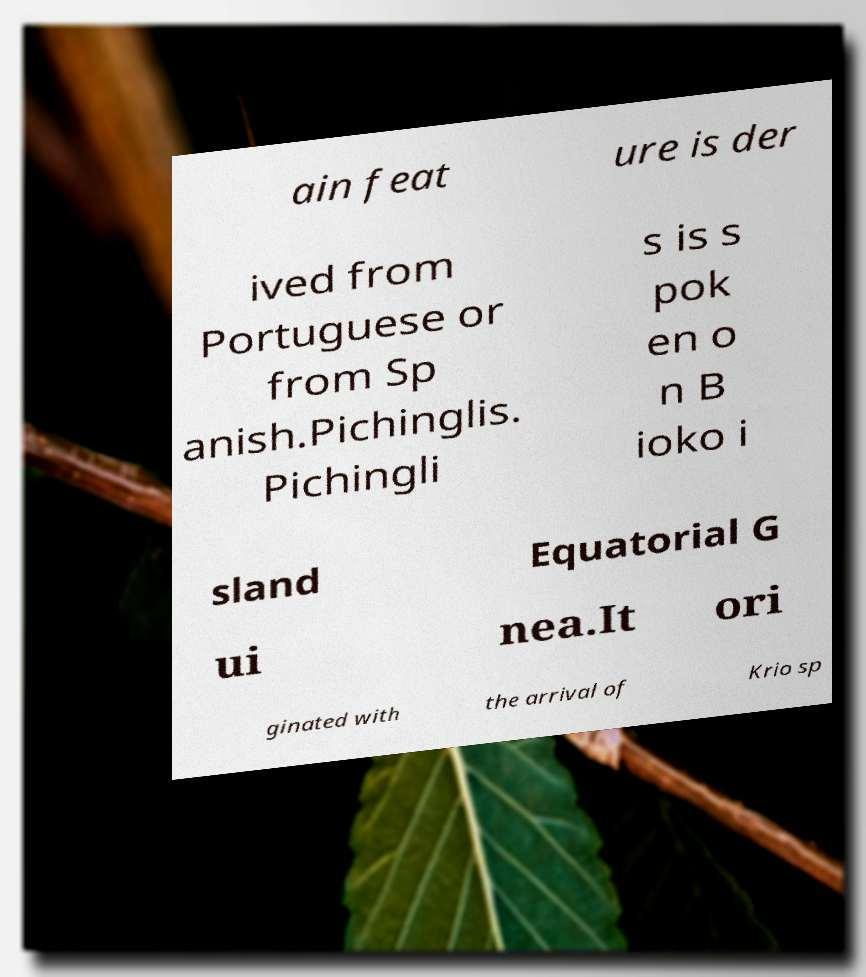Can you read and provide the text displayed in the image?This photo seems to have some interesting text. Can you extract and type it out for me? ain feat ure is der ived from Portuguese or from Sp anish.Pichinglis. Pichingli s is s pok en o n B ioko i sland Equatorial G ui nea.It ori ginated with the arrival of Krio sp 